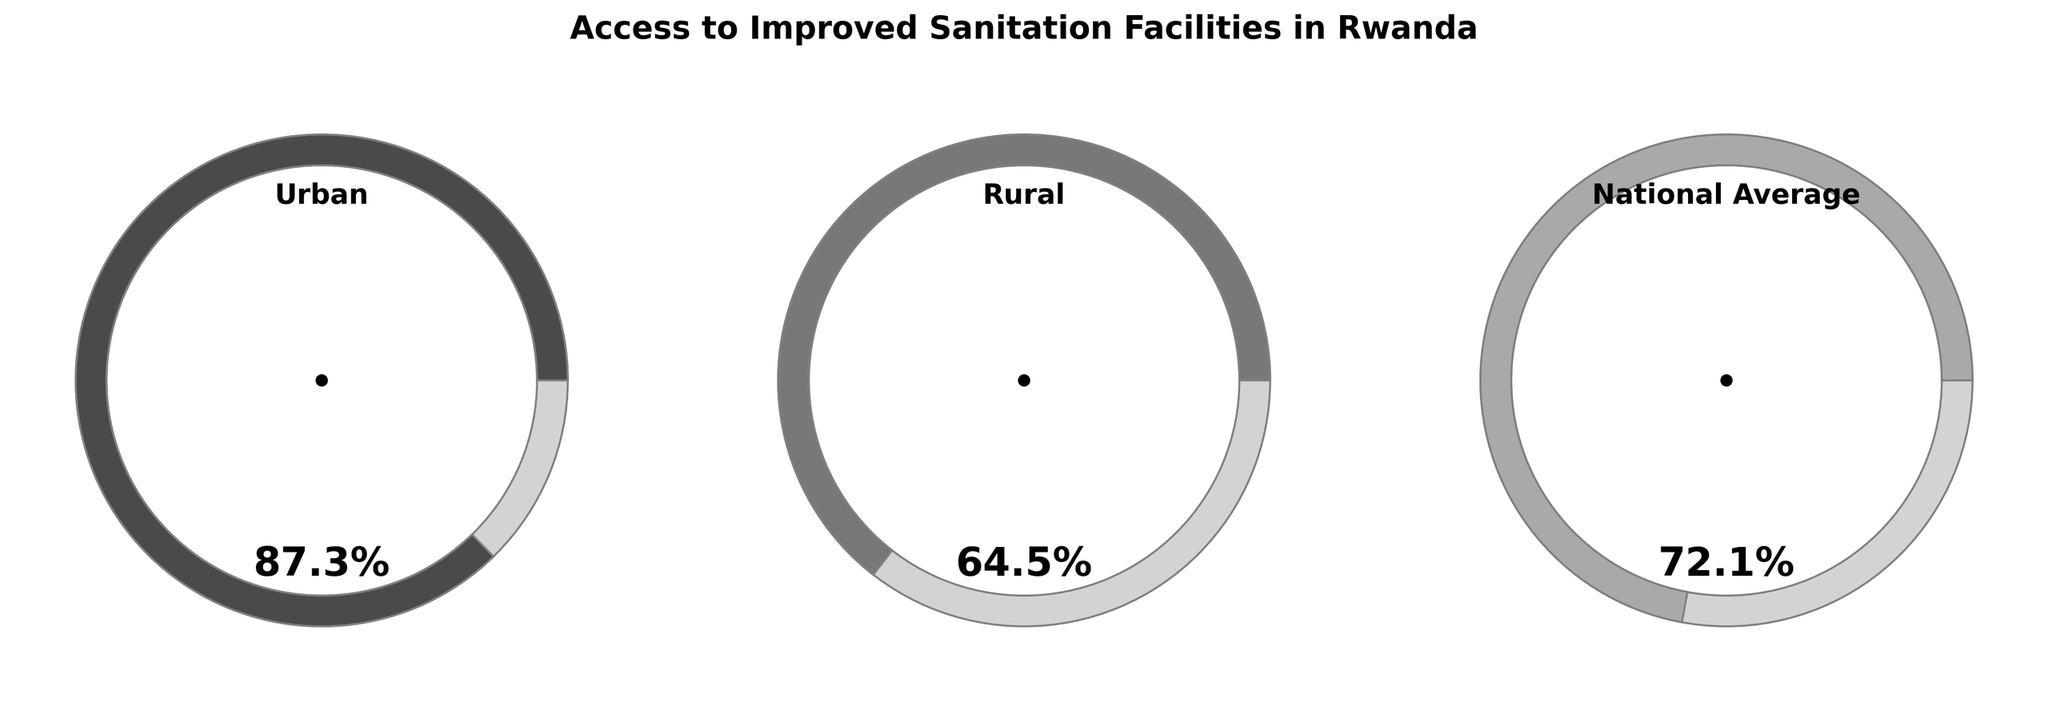What is the percentage of urban households with access to improved sanitation facilities? The gauge chart for urban households shows a percentage of 87.3% indicated by the marker on the chart.
Answer: 87.3% How does the percentage of rural households compare to urban households in terms of access to improved sanitation facilities? The gauge chart for rural households shows 64.5%, and the urban households' chart shows 87.3%. Comparing these, urban households have a higher percentage.
Answer: Urban households have a higher percentage By how much does the national average percentage of households with access to improved sanitation differ from the urban percentage? The national average chart shows 72.1% and the urban chart shows 87.3%. The difference is calculated as 87.3% - 72.1% = 15.2%.
Answer: 15.2% Which area has the lowest percentage of households with access to improved sanitation facilities? The gauge charts show the percentages for Urban (87.3%), Rural (64.5%), and National Average (72.1%). The rural area has the lowest percentage.
Answer: Rural What is the difference in the percentage of households with access to improved sanitation facilities between rural areas and the national average? The rural area's chart shows 64.5% and the national average shows 72.1%. The difference is calculated as 72.1% - 64.5% = 7.6%.
Answer: 7.6% What can be inferred about the sanitation facilities status based on the gauge chart colors? The gauge charts for urban, rural, and national categories use different shades of gray, ranging from darker to lighter. The urban gauge is dark gray, indicating the highest value, while rural is lighter gray, indicating a lower value. The national average is a medium gray, lying between urban and rural. This color differentiation helps in distinguishing the levels easily.
Answer: Urban has the darkest gray (highest), Rural has the lightest gray (lowest) How do the scales on the gauge charts help with the interpretation of the data? The scales on the gauge charts range from 0 to 100%, with a circular arc design. The filled portions on the chart indicate the percentage values for urban (87.3%), rural (64.5%), and national average (72.1%). This visual representation allows for a quick comparison between categories.
Answer: The scales make it easy to compare urban, rural, and national average percentages What does the national average indicate in terms of improved sanitation facilities access? The national average gauge chart shows a percentage of 72.1%. This indicates that, on average, 72.1% of all Rwandan households, both urban and rural, have access to improved sanitation facilities.
Answer: 72.1% 